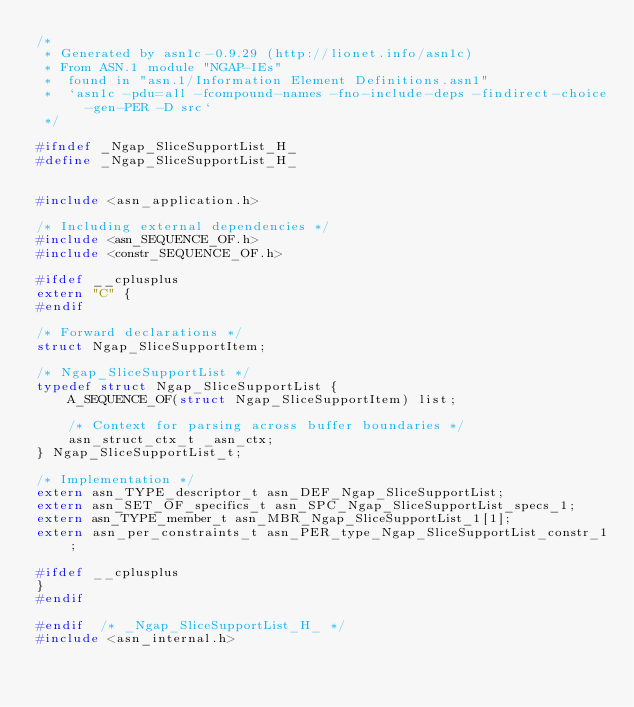Convert code to text. <code><loc_0><loc_0><loc_500><loc_500><_C_>/*
 * Generated by asn1c-0.9.29 (http://lionet.info/asn1c)
 * From ASN.1 module "NGAP-IEs"
 * 	found in "asn.1/Information Element Definitions.asn1"
 * 	`asn1c -pdu=all -fcompound-names -fno-include-deps -findirect-choice -gen-PER -D src`
 */

#ifndef	_Ngap_SliceSupportList_H_
#define	_Ngap_SliceSupportList_H_


#include <asn_application.h>

/* Including external dependencies */
#include <asn_SEQUENCE_OF.h>
#include <constr_SEQUENCE_OF.h>

#ifdef __cplusplus
extern "C" {
#endif

/* Forward declarations */
struct Ngap_SliceSupportItem;

/* Ngap_SliceSupportList */
typedef struct Ngap_SliceSupportList {
	A_SEQUENCE_OF(struct Ngap_SliceSupportItem) list;
	
	/* Context for parsing across buffer boundaries */
	asn_struct_ctx_t _asn_ctx;
} Ngap_SliceSupportList_t;

/* Implementation */
extern asn_TYPE_descriptor_t asn_DEF_Ngap_SliceSupportList;
extern asn_SET_OF_specifics_t asn_SPC_Ngap_SliceSupportList_specs_1;
extern asn_TYPE_member_t asn_MBR_Ngap_SliceSupportList_1[1];
extern asn_per_constraints_t asn_PER_type_Ngap_SliceSupportList_constr_1;

#ifdef __cplusplus
}
#endif

#endif	/* _Ngap_SliceSupportList_H_ */
#include <asn_internal.h>
</code> 